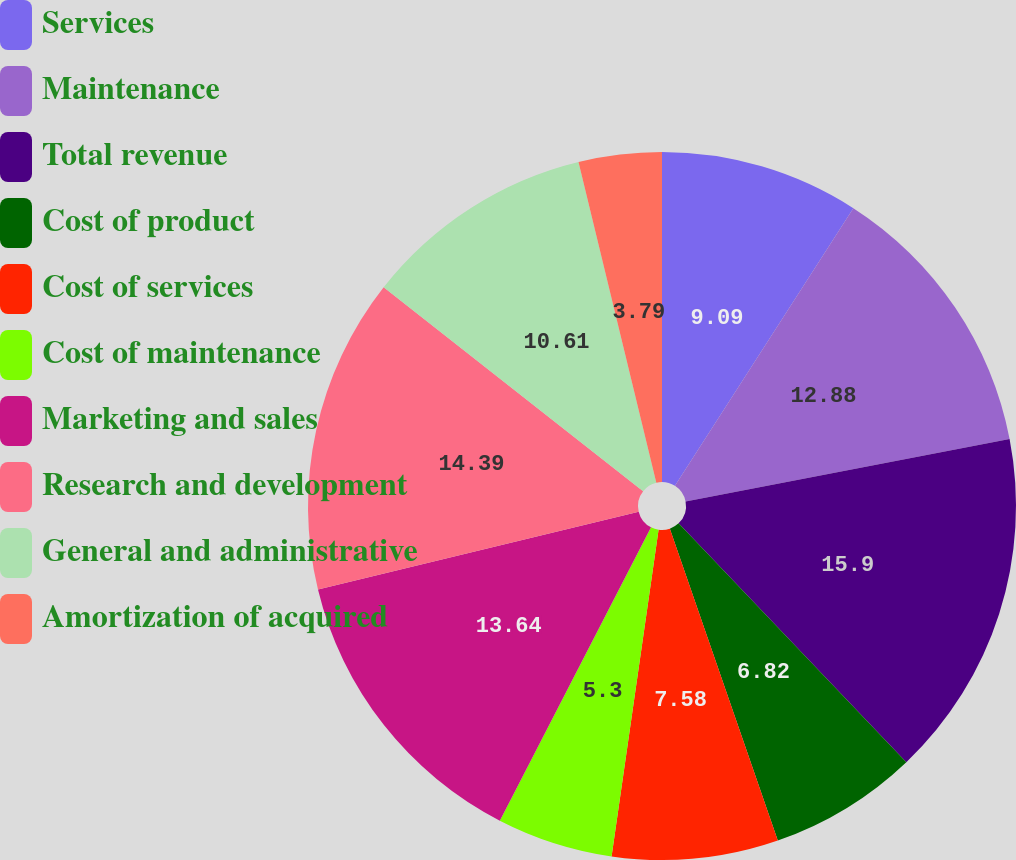Convert chart to OTSL. <chart><loc_0><loc_0><loc_500><loc_500><pie_chart><fcel>Services<fcel>Maintenance<fcel>Total revenue<fcel>Cost of product<fcel>Cost of services<fcel>Cost of maintenance<fcel>Marketing and sales<fcel>Research and development<fcel>General and administrative<fcel>Amortization of acquired<nl><fcel>9.09%<fcel>12.88%<fcel>15.91%<fcel>6.82%<fcel>7.58%<fcel>5.3%<fcel>13.64%<fcel>14.39%<fcel>10.61%<fcel>3.79%<nl></chart> 